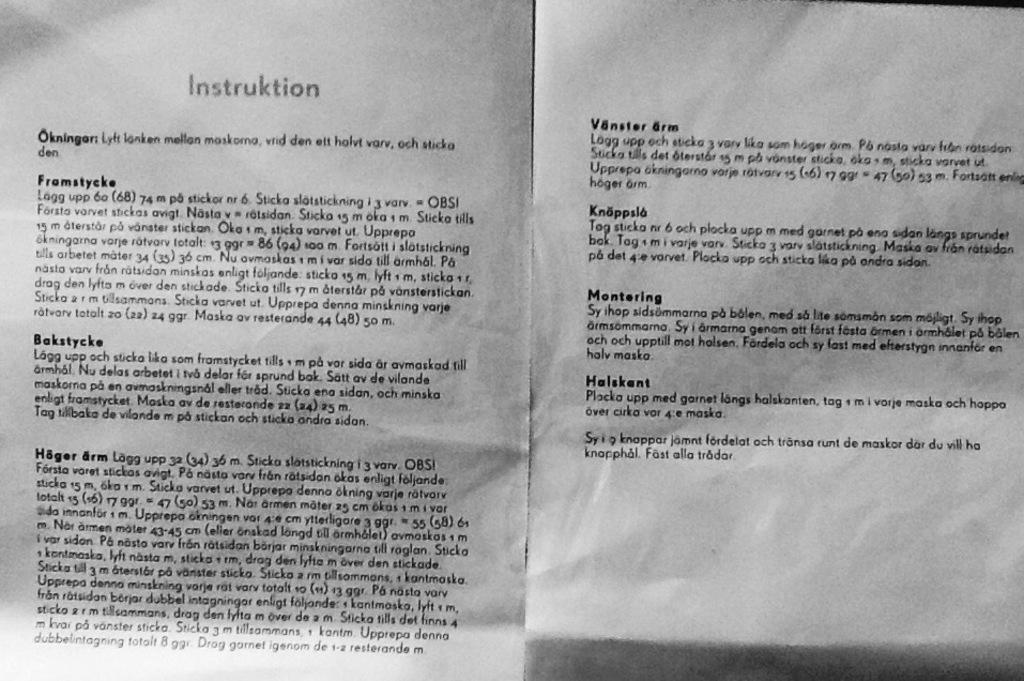Provide a one-sentence caption for the provided image. A scan two pages of some kind of foreign instructions. 